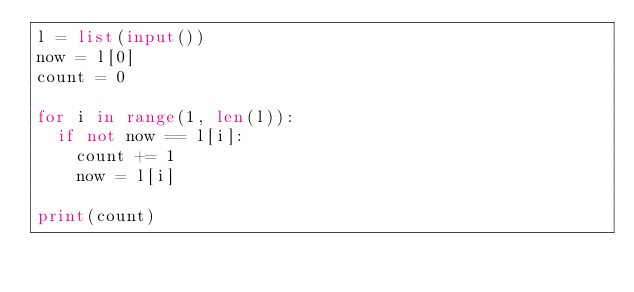Convert code to text. <code><loc_0><loc_0><loc_500><loc_500><_Python_>l = list(input())
now = l[0]
count = 0

for i in range(1, len(l)):
  if not now == l[i]:
    count += 1
    now = l[i]

print(count)</code> 